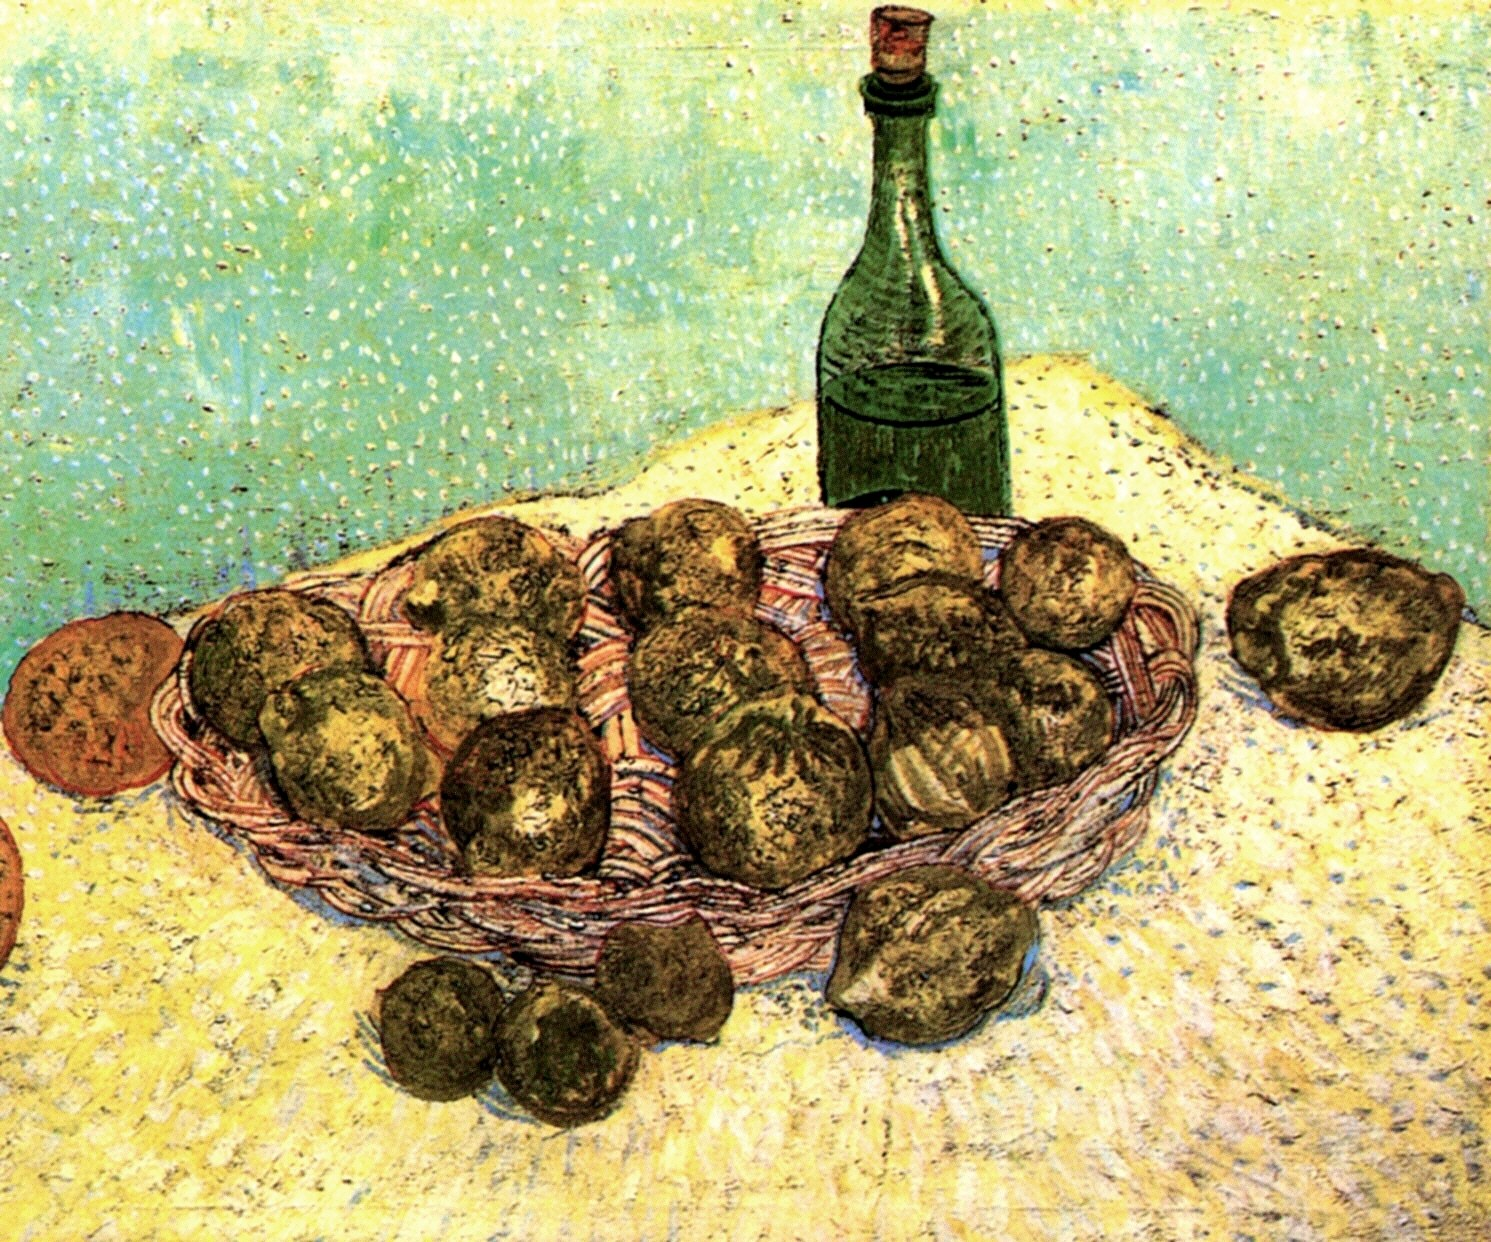What do you think is going on in this snapshot? The image displays a still life painting that exemplifies the post-impressionistic style, possibly inspired by artists like Vincent Van Gogh. It features a basket brimming with potatoes, situated next to a green bottle, all placed on a vibrant yellow surface. The textured strokes and bold, contrasting use of colors are typical of post-impressionism, an art movement that valued expressive color and visible brushwork over realistic representation. This painting not only captures daily elements in a bold, new perspective but also evokes a sense of rustic simplicity and the beauty of ordinary objects. 